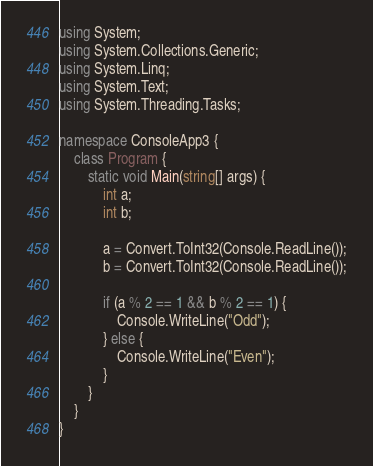<code> <loc_0><loc_0><loc_500><loc_500><_C#_>using System;
using System.Collections.Generic;
using System.Linq;
using System.Text;
using System.Threading.Tasks;

namespace ConsoleApp3 {
    class Program {
        static void Main(string[] args) {
            int a;
            int b;

            a = Convert.ToInt32(Console.ReadLine());
            b = Convert.ToInt32(Console.ReadLine());

            if (a % 2 == 1 && b % 2 == 1) {
                Console.WriteLine("Odd");
            } else {
                Console.WriteLine("Even");
            }
        }
    }
}
</code> 